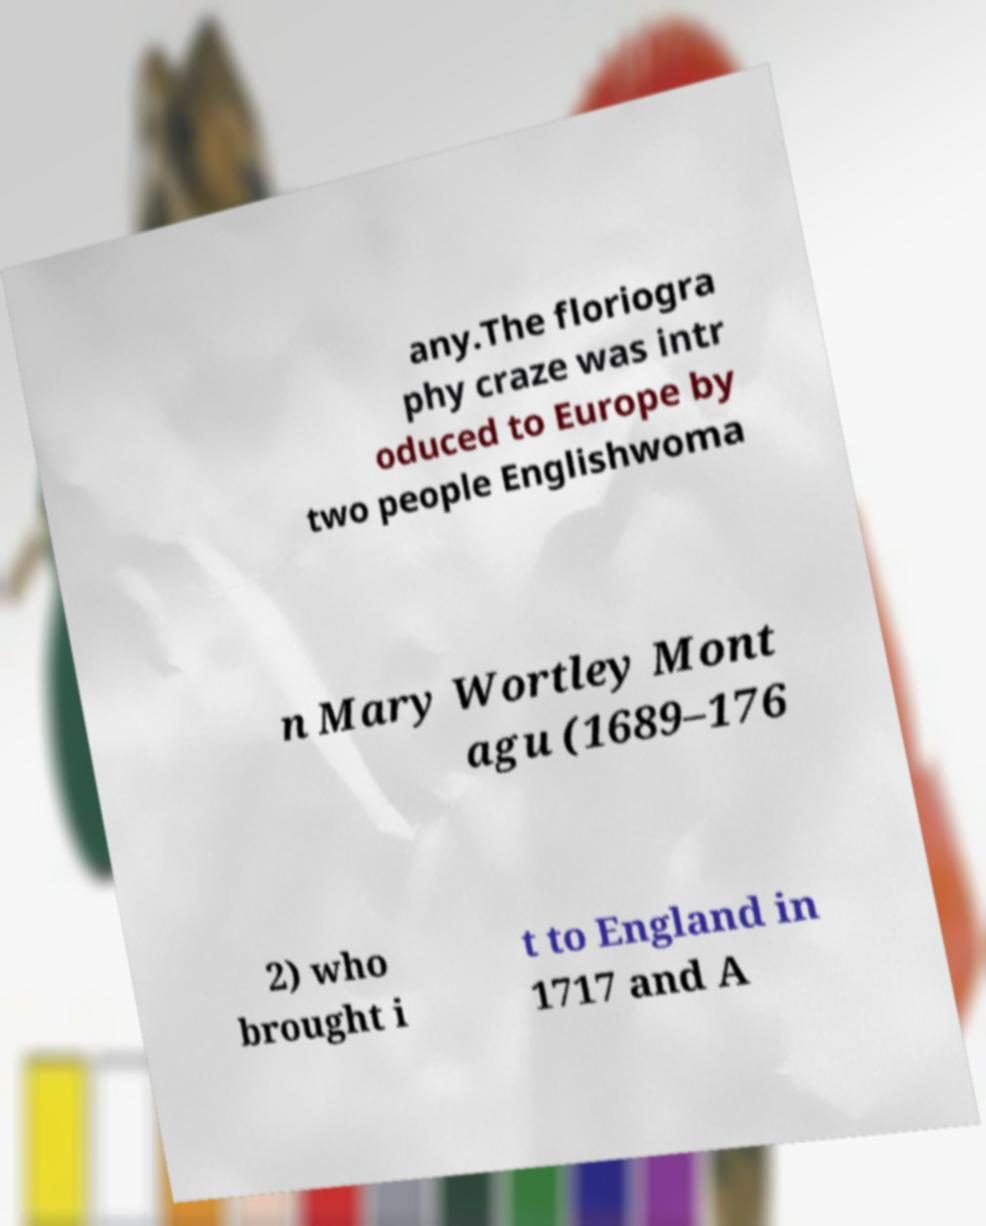Could you assist in decoding the text presented in this image and type it out clearly? any.The floriogra phy craze was intr oduced to Europe by two people Englishwoma n Mary Wortley Mont agu (1689–176 2) who brought i t to England in 1717 and A 